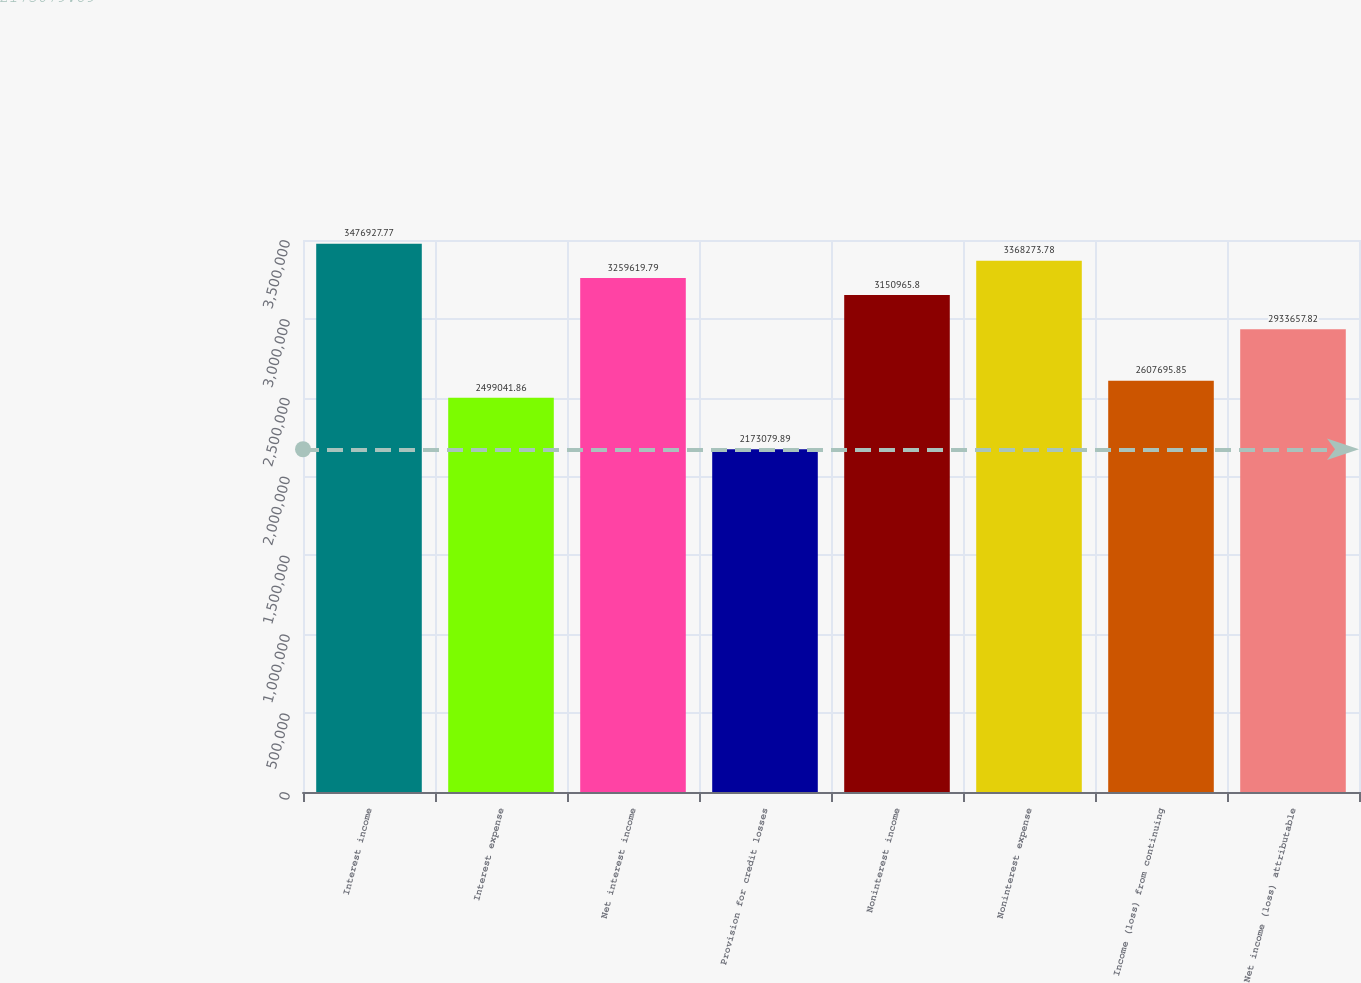Convert chart. <chart><loc_0><loc_0><loc_500><loc_500><bar_chart><fcel>Interest income<fcel>Interest expense<fcel>Net interest income<fcel>Provision for credit losses<fcel>Noninterest income<fcel>Noninterest expense<fcel>Income (loss) from continuing<fcel>Net income (loss) attributable<nl><fcel>3.47693e+06<fcel>2.49904e+06<fcel>3.25962e+06<fcel>2.17308e+06<fcel>3.15097e+06<fcel>3.36827e+06<fcel>2.6077e+06<fcel>2.93366e+06<nl></chart> 